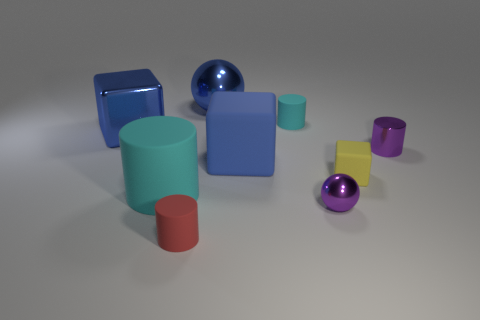Subtract 1 cylinders. How many cylinders are left? 3 Subtract all blocks. How many objects are left? 6 Subtract all rubber blocks. Subtract all small brown rubber things. How many objects are left? 7 Add 3 tiny metallic balls. How many tiny metallic balls are left? 4 Add 3 large brown cylinders. How many large brown cylinders exist? 3 Subtract 0 brown cubes. How many objects are left? 9 